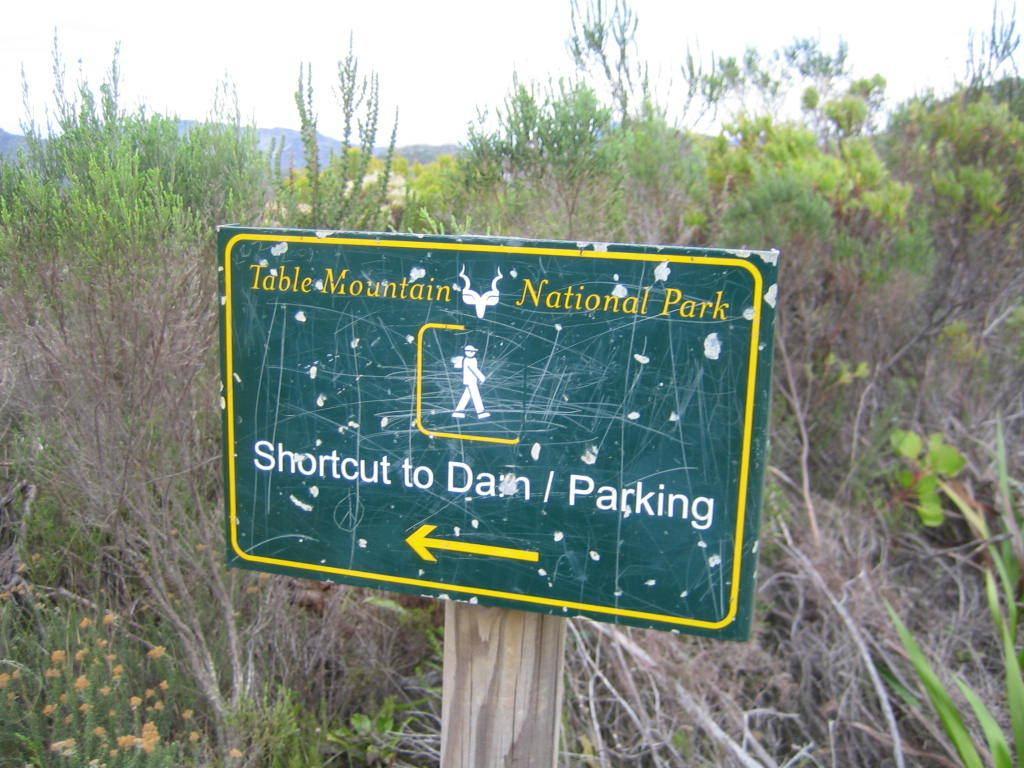Describe this image in one or two sentences. There is a green board at the center. It has yellow borders and a yellow arrow at the bottom. There are plants behind it and there is sky on the top. 